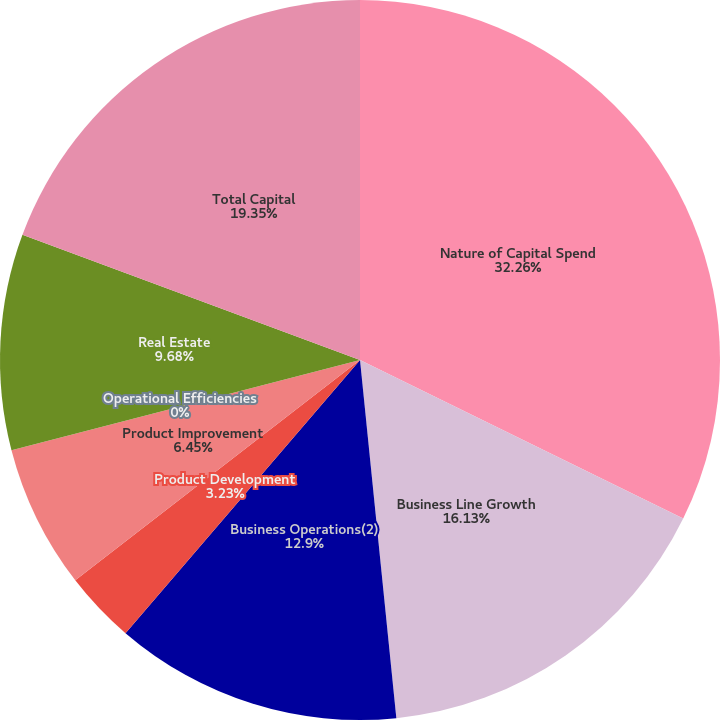Convert chart to OTSL. <chart><loc_0><loc_0><loc_500><loc_500><pie_chart><fcel>Nature of Capital Spend<fcel>Business Line Growth<fcel>Business Operations(2)<fcel>Product Development<fcel>Product Improvement<fcel>Operational Efficiencies<fcel>Real Estate<fcel>Total Capital<nl><fcel>32.26%<fcel>16.13%<fcel>12.9%<fcel>3.23%<fcel>6.45%<fcel>0.0%<fcel>9.68%<fcel>19.35%<nl></chart> 